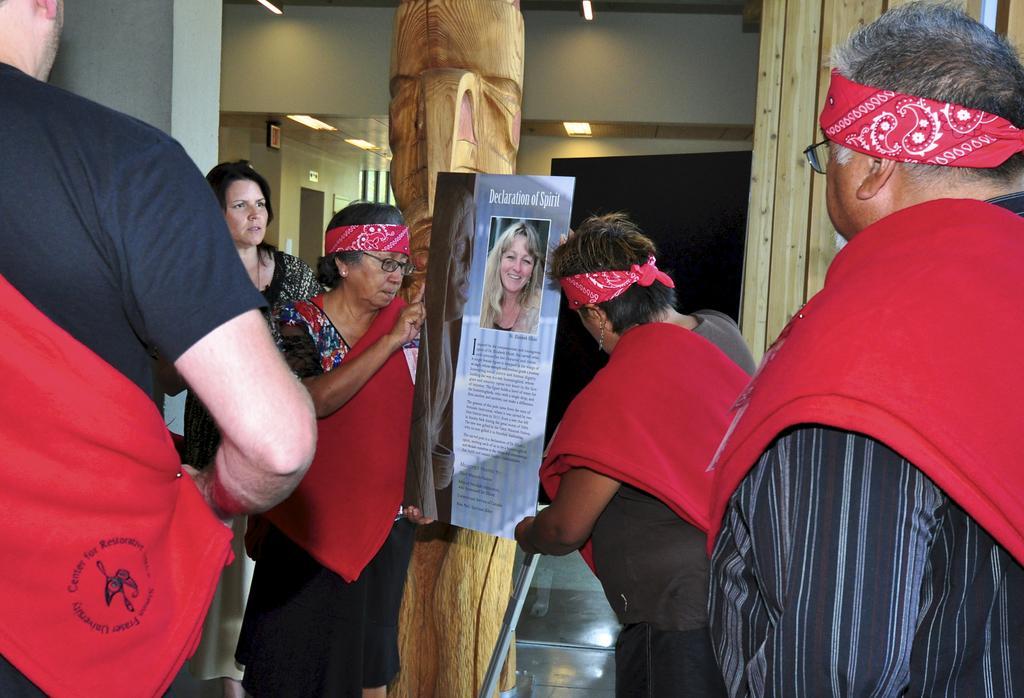Please provide a concise description of this image. In this image I can see group of people standing in a room in which few of them holding posters, also there is a pillar in the middle. 